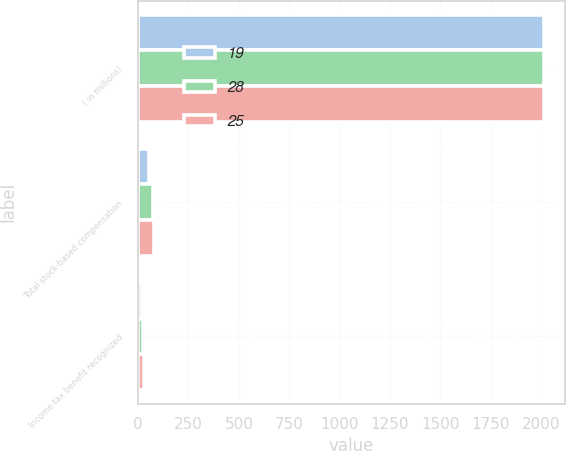Convert chart. <chart><loc_0><loc_0><loc_500><loc_500><stacked_bar_chart><ecel><fcel>( in millions)<fcel>Total stock-based compensation<fcel>Income tax benefit recognized<nl><fcel>19<fcel>2015<fcel>56<fcel>19<nl><fcel>28<fcel>2014<fcel>73<fcel>25<nl><fcel>25<fcel>2013<fcel>81<fcel>28<nl></chart> 